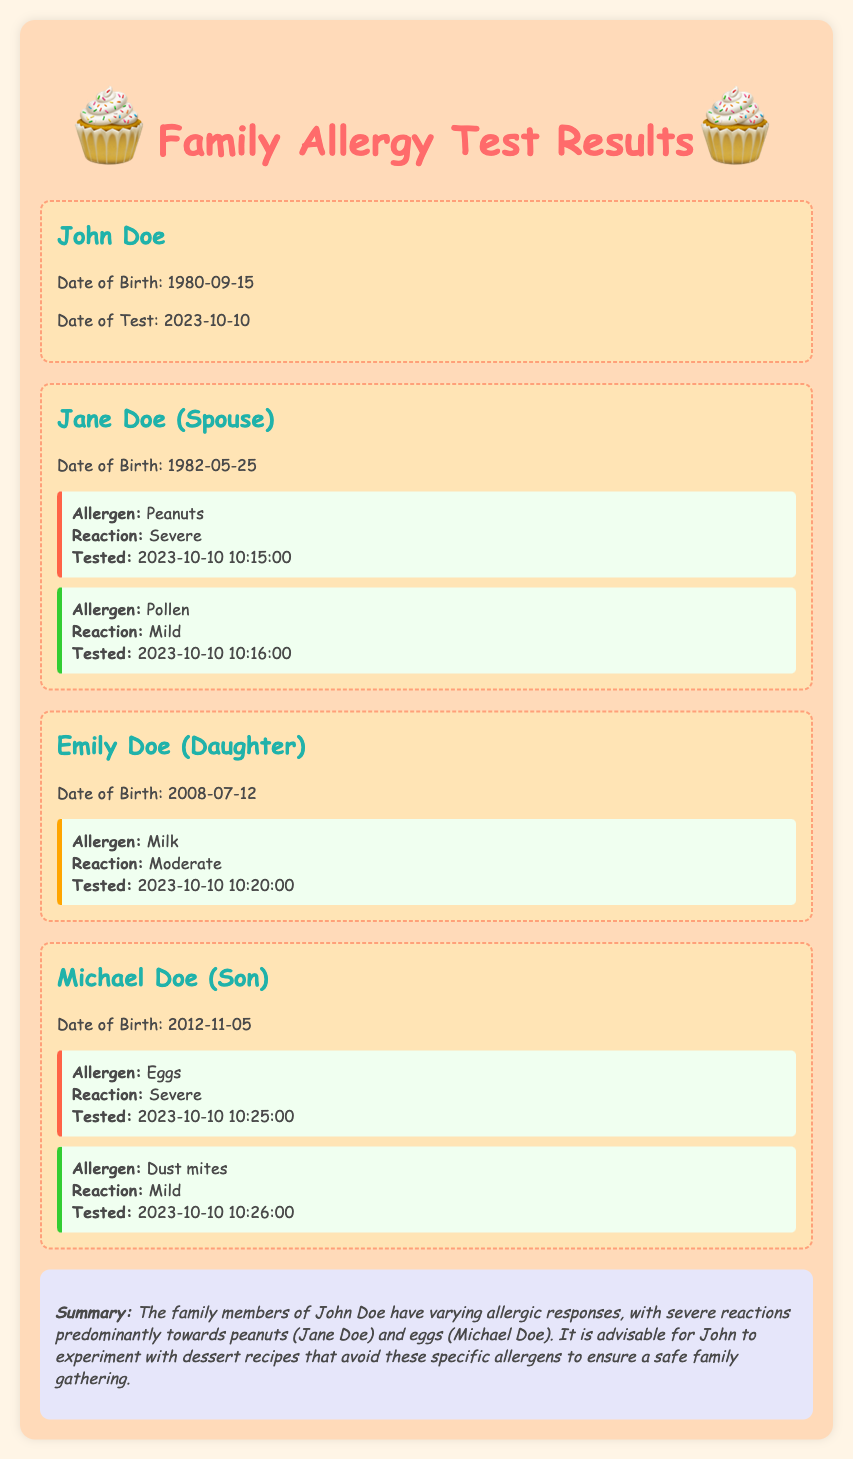What is the name of the first family member? The first family member listed in the document is John Doe.
Answer: John Doe What allergen causes a severe reaction in Jane Doe? The allergen causing a severe reaction in Jane Doe is Peanuts.
Answer: Peanuts What is Emily Doe's date of birth? Emily Doe's date of birth is listed to understand her age in relation to allergies.
Answer: 2008-07-12 Which family member has a moderate reaction to an allergen? Emily Doe has a moderate reaction, which is important for understanding her allergy severity.
Answer: Emily Doe As of what date were the allergy tests conducted? The allergy tests were conducted on the same date for all family members.
Answer: 2023-10-10 What is the summary advice regarding dessert recipes for the family? The summary suggests avoiding specific allergens when preparing desserts for family gatherings.
Answer: Avoid peanuts and eggs 